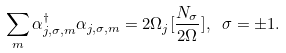<formula> <loc_0><loc_0><loc_500><loc_500>\sum _ { m } \alpha _ { j , \sigma , m } ^ { \dagger } \alpha _ { j , \sigma , m } = 2 \Omega _ { j } [ \frac { N _ { \sigma } } { 2 \Omega } ] , \ \sigma = \pm 1 .</formula> 